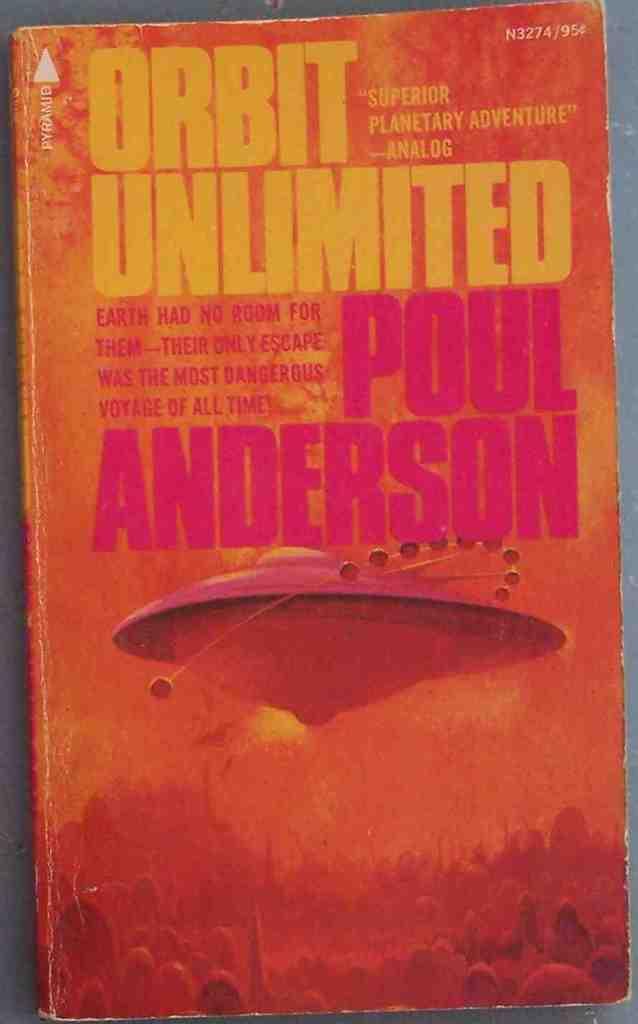What is the title of the book?
Your answer should be very brief. Orbit unlimited. Who wrote this book?
Provide a short and direct response. Poul anderson. 